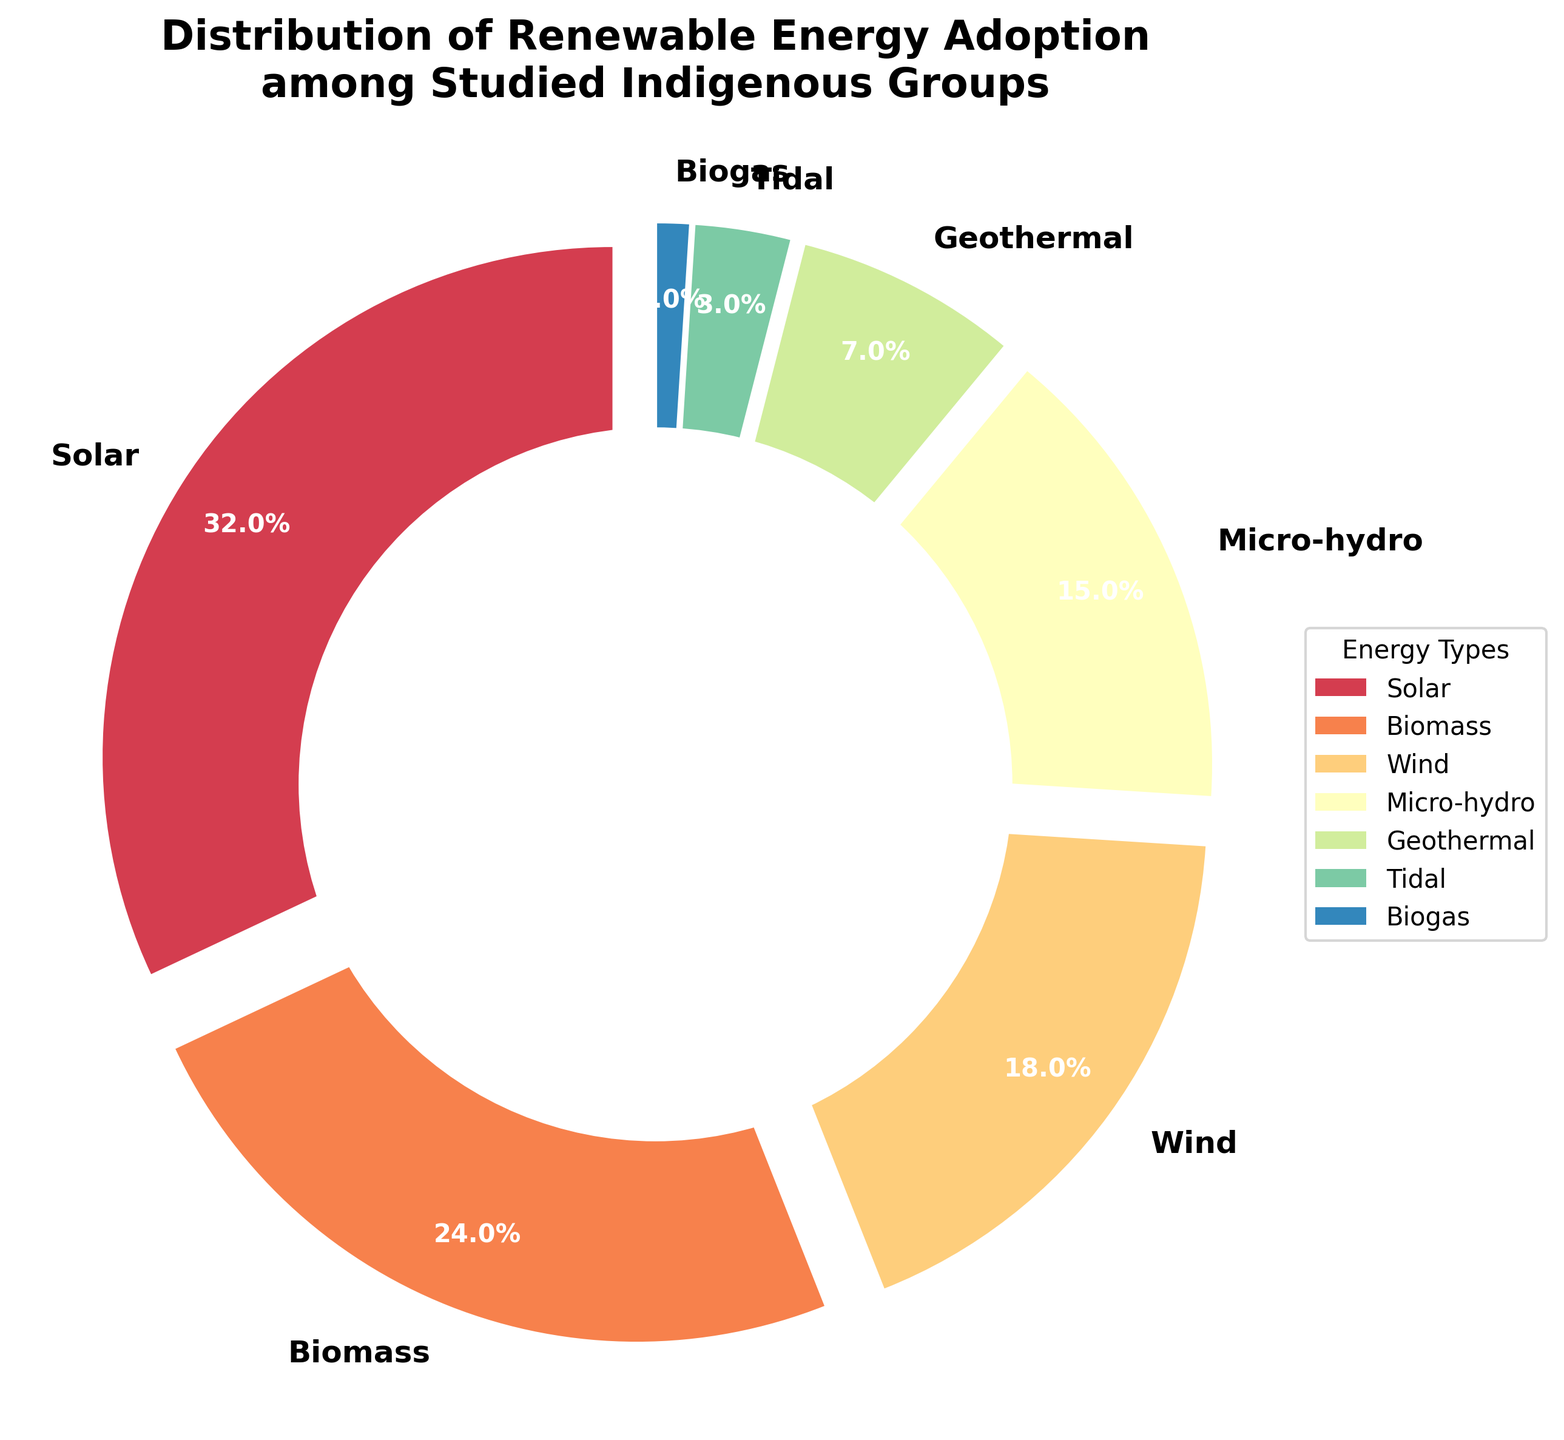What's the combined percentage of Solar and Biomass adoption? The figure shows that Solar adoption is 32% and Biomass adoption is 24%. Add these two values together: 32% + 24% = 56%.
Answer: 56% Which renewable energy type has the lowest adoption percentage? By looking at the figure, we see that Biogas has the lowest percentage, which is 1%.
Answer: Biogas How much more prevalent is Solar compared to Wind adoption? The figure shows Solar adoption at 32% and Wind adoption at 18%. The difference is 32% - 18% = 14%.
Answer: 14% What is the average adoption percentage of Micro-hydro and Geothermal energies? The figure shows Micro-hydro adoption at 15% and Geothermal adoption at 7%. The average is calculated as (15% + 7%) / 2 = 11%.
Answer: 11% How does the adoption of Tidal energy compare to Biogas adoption? The figure shows Tidal energy adoption at 3% and Biogas adoption at 1%. Tidal energy adoption is 2% higher than Biogas adoption.
Answer: Tidal has 2% more What percentage of the chart is not represented by Solar, Biomass, and Wind? Solar, Biomass, and Wind adoption percentages are 32%, 24%, and 18%, respectively. Their combined percentage is 32% + 24% + 18% = 74%. The remaining percentage is 100% - 74% = 26%.
Answer: 26% List the renewable energy types in descending order of adoption percentage. The renewable energy types and their adoption percentages are: Solar (32%), Biomass (24%), Wind (18%), Micro-hydro (15%), Geothermal (7%), Tidal (3%), Biogas (1%). In descending order, they are: Solar, Biomass, Wind, Micro-hydro, Geothermal, Tidal, Biogas.
Answer: Solar, Biomass, Wind, Micro-hydro, Geothermal, Tidal, Biogas How many renewable energy types have an adoption percentage less than 10%? From the figure, the energies with less than 10% adoption are Geothermal (7%), Tidal (3%), and Biogas (1%). There are 3 energy types in total.
Answer: 3 